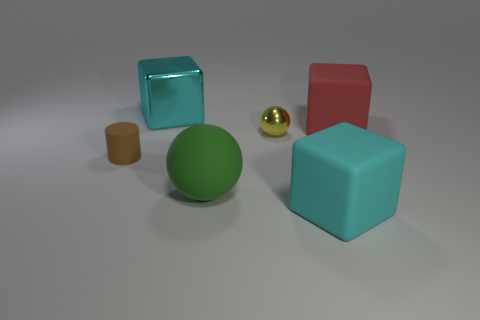Subtract all cyan blocks. How many blocks are left? 1 Add 1 yellow rubber cylinders. How many objects exist? 7 Subtract all cylinders. How many objects are left? 5 Add 2 balls. How many balls exist? 4 Subtract 0 cyan spheres. How many objects are left? 6 Subtract all rubber cubes. Subtract all matte spheres. How many objects are left? 3 Add 5 matte objects. How many matte objects are left? 9 